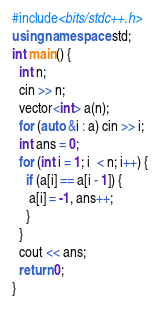<code> <loc_0><loc_0><loc_500><loc_500><_C++_>#include<bits/stdc++.h>
using namespace std;
int main() {
  int n;
  cin >> n;
  vector<int> a(n);
  for (auto &i : a) cin >> i;
  int ans = 0;
  for (int i = 1; i  < n; i++) {
    if (a[i] == a[i - 1]) {
     a[i] = -1, ans++;
    }
  }
  cout << ans;
  return 0;
}</code> 